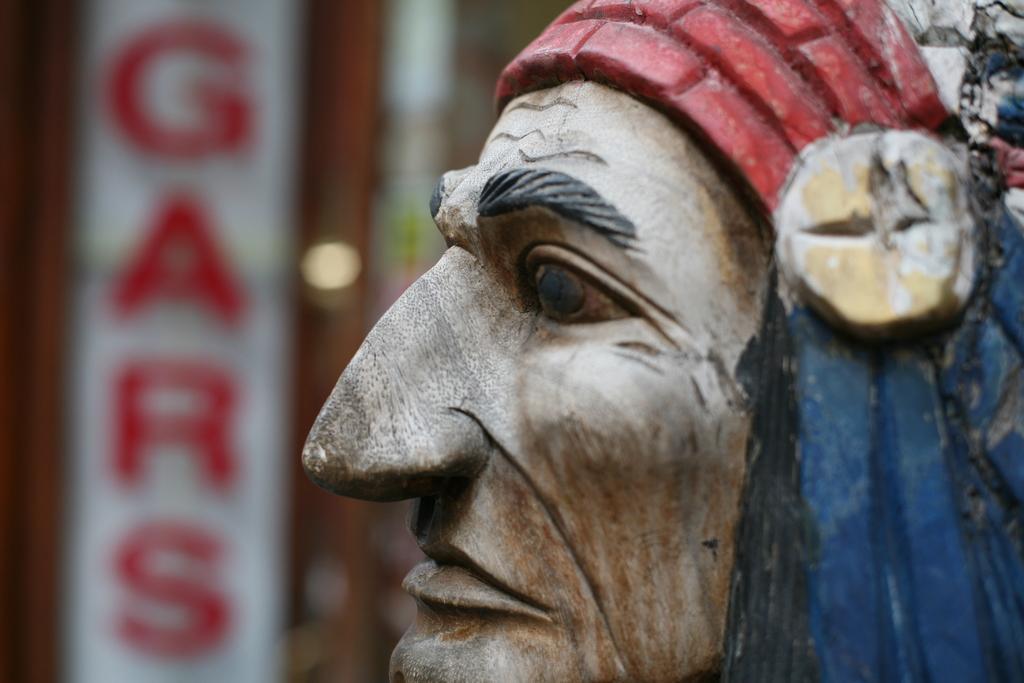Could you give a brief overview of what you see in this image? In this image in the front there is a sculpture. In the background there is a board with some text written on it. 